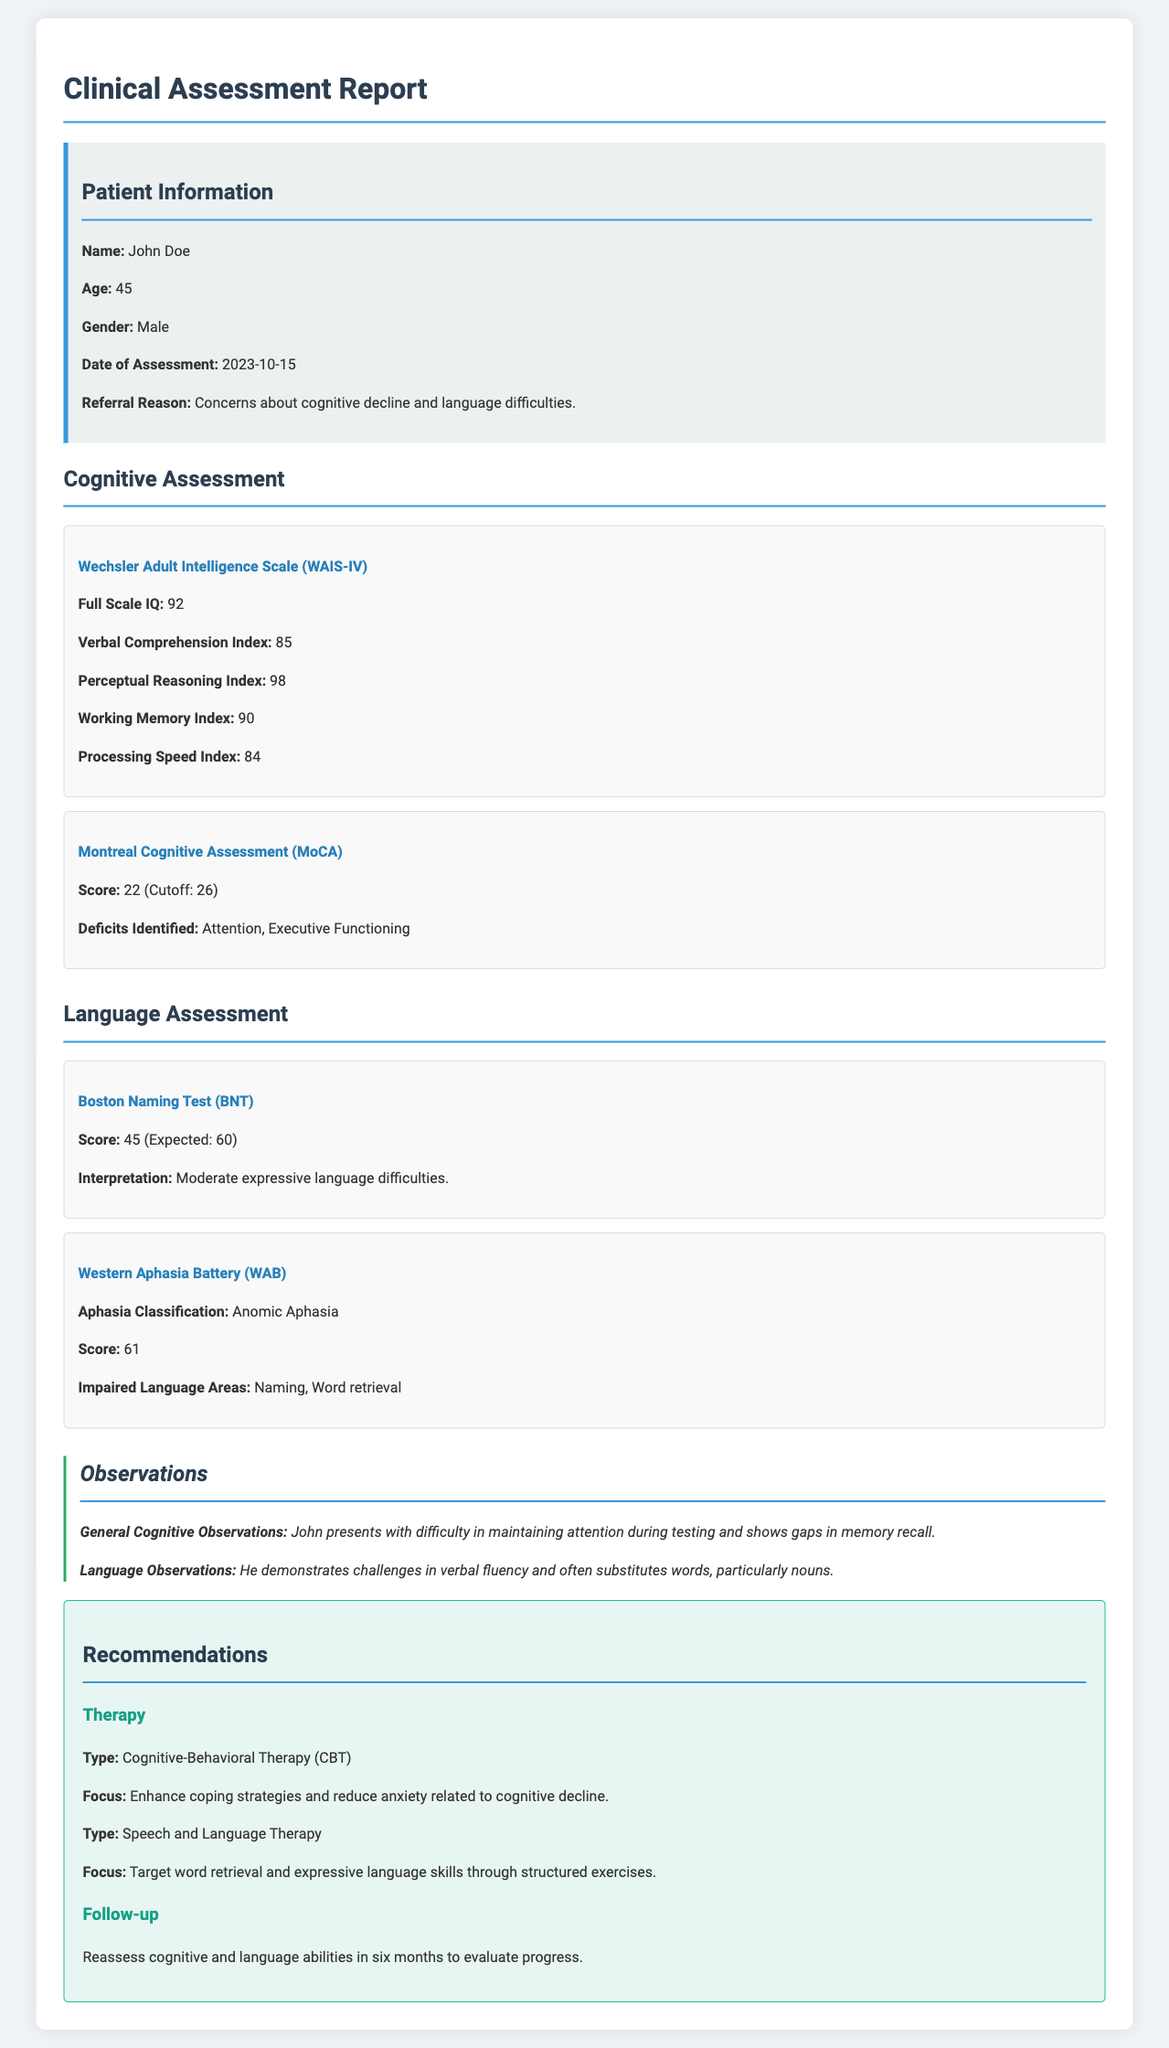What is the patient's name? The document provides the patient's information section, which states John's name.
Answer: John Doe What is the patient's age? The patient's age is clearly stated in the patient information section of the document.
Answer: 45 What is the score on the Montreal Cognitive Assessment? The score for the Montreal Cognitive Assessment is provided under the cognitive assessment section.
Answer: 22 What type of aphasia was classified in the Western Aphasia Battery? The document specifies the aphasia classification found in the language assessment section.
Answer: Anomic Aphasia What is the recommended therapy for enhancing coping strategies? The recommendations section lists the types of therapy recommended, including a focus on coping strategies.
Answer: Cognitive-Behavioral Therapy (CBT) What deficits were identified in the MoCA? The document notes specific deficits identified in the Montreal Cognitive Assessment results.
Answer: Attention, Executive Functioning What is the suggested follow-up timeframe for reassessment? The recommendations detail the timeframe for follow-up to evaluate progress.
Answer: Six months What is noted about John's work retrieval abilities? Observations section mentions areas where John faces challenges during assessments.
Answer: Naming, Word retrieval What is the score for the Boston Naming Test? The score for the Boston Naming Test is included under the language assessment results.
Answer: 45 